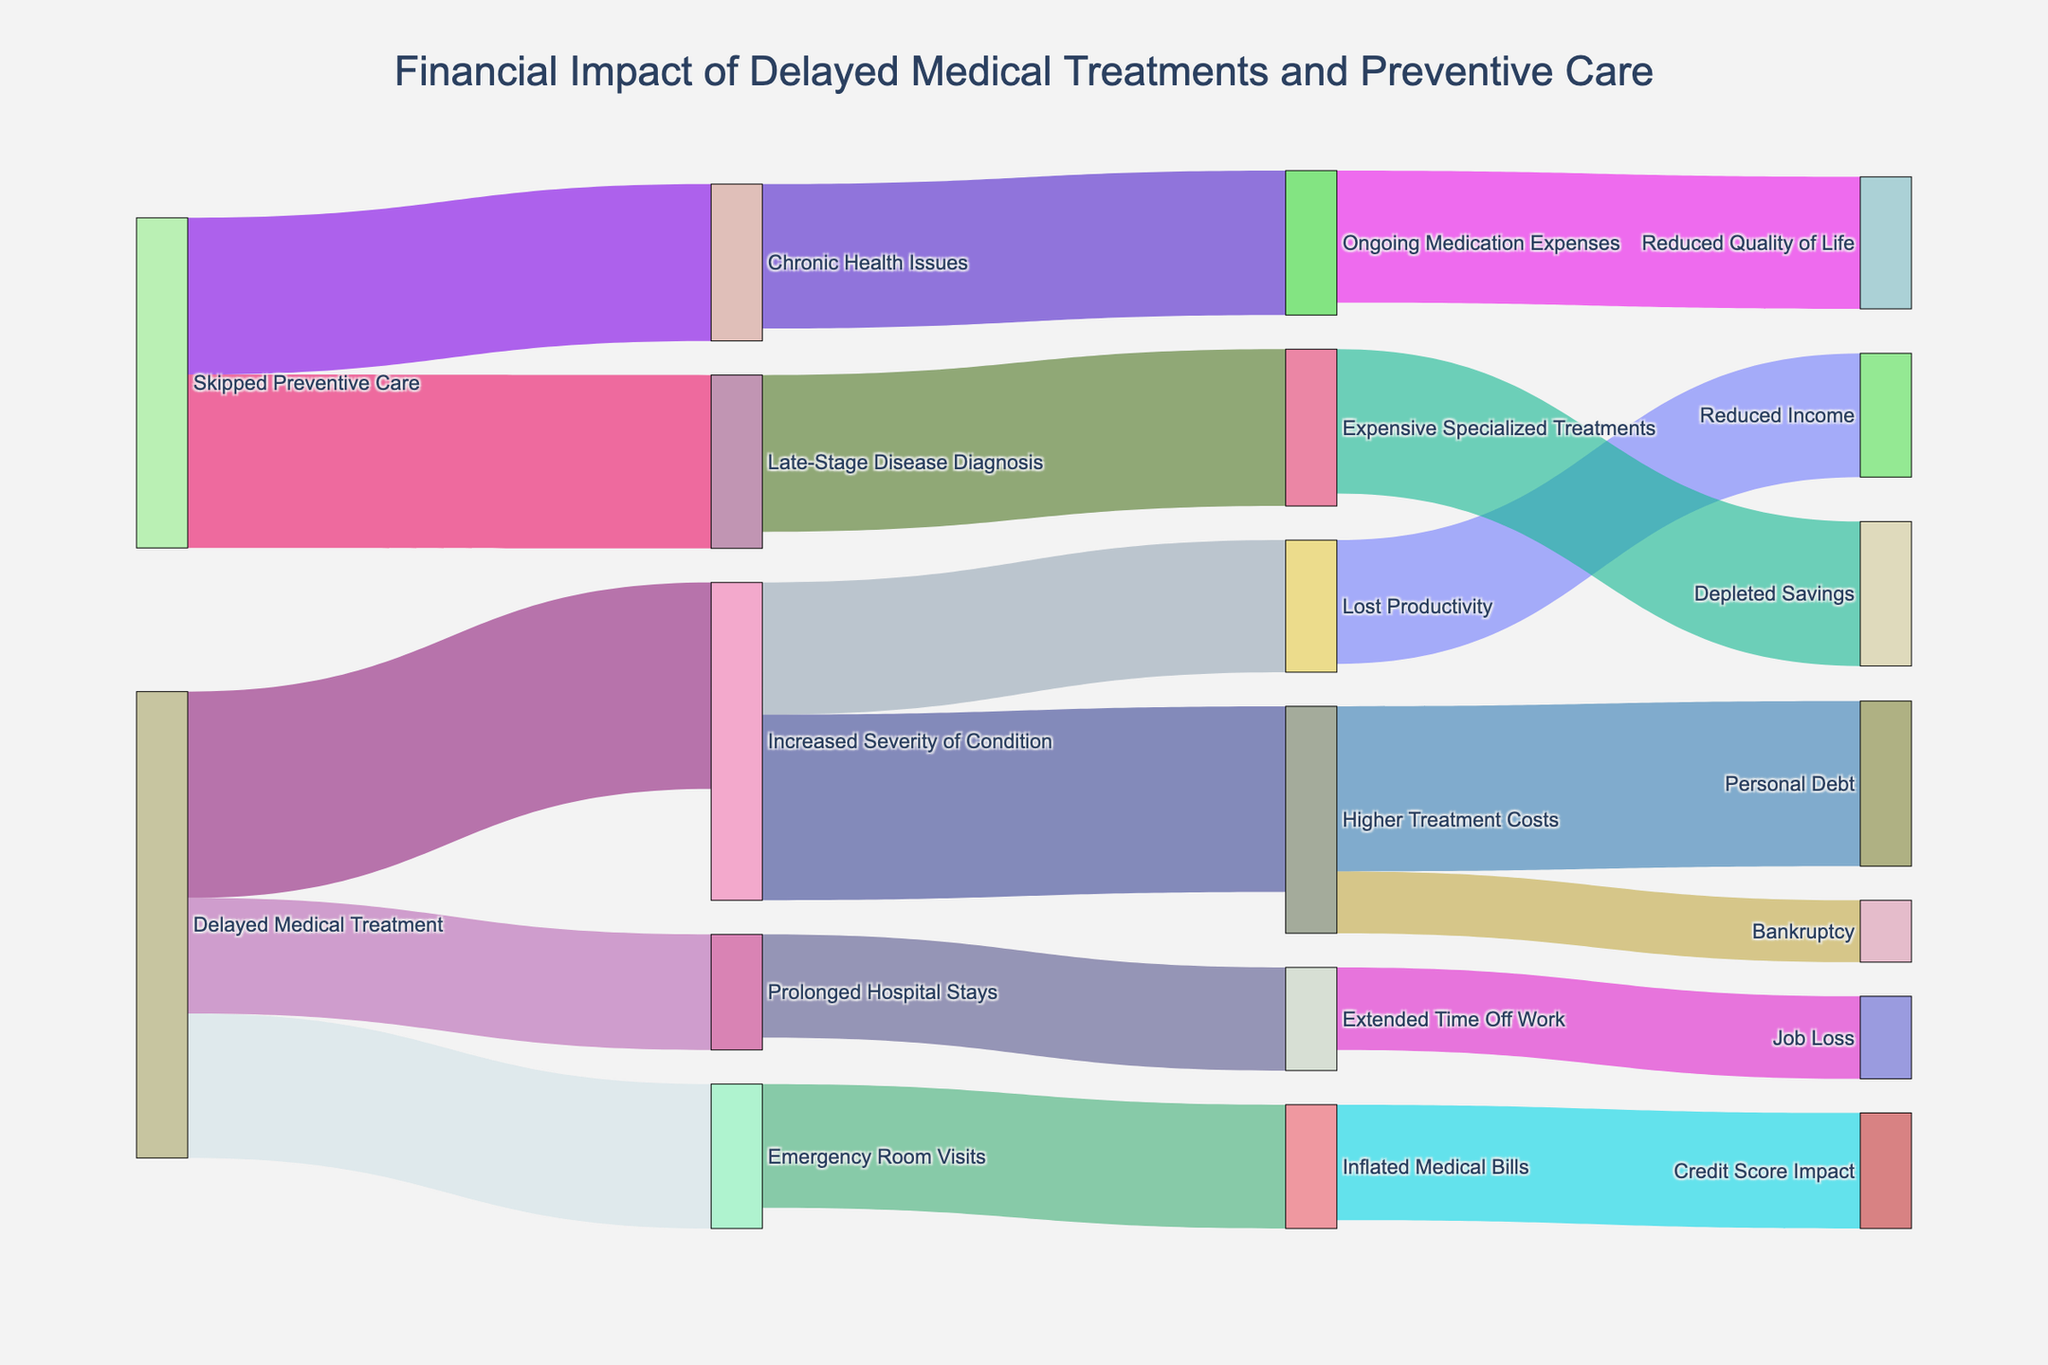What's the title of the diagram? The title is usually located at the top of the figure, providing a summary of the diagram's purpose. In this case, it should reflect the main focus of the Sankey Diagram.
Answer: Financial Impact of Delayed Medical Treatments and Preventive Care How many main pathways originate from "Delayed Medical Treatment"? To answer this, look for lines or arrows (links) starting from the "Delayed Medical Treatment" node. Count the total number of these links.
Answer: 3 What is the highest value link originating from "Skipped Preventive Care"? Identify the links originating from "Skipped Preventive Care" and compare their values. The highest value will be the largest number assigned to a link.
Answer: 4200 Which consequence has the highest value linked to "Emergency Room Visits"? Look at the arrows stemming from "Emergency Room Visits" and compare their values. The one with the highest number represents the biggest consequence.
Answer: Inflated Medical Bills What is the combined value of links leading to "Higher Treatment Costs"? Identify all the nodes directing to "Higher Treatment Costs" and sum their values. This requires adding each value linked to this target node.
Answer: 5000 How does the value of "Extended Time Off Work" compare to "Job Loss"? Compare the numerical values associated with "Extended Time Off Work" and "Job Loss" to see which is greater or if they are equal.
Answer: Extended Time Off Work is greater What is the total value related to "Increased Severity of Condition"? Sum up all the values stemming from the "Increased Severity of Condition" node to get the total impact. This works by adding each numerical value linked to it.
Answer: 7700 Between "Chronic Health Issues" and "Prolonged Hospital Stays," which node has a higher sum of consequential impacts? Identify the nodes linked to "Chronic Health Issues" and "Prolonged Hospital Stays" and sum their subsequent values. Compare these totals to determine which is higher.
Answer: Chronic Health Issues 